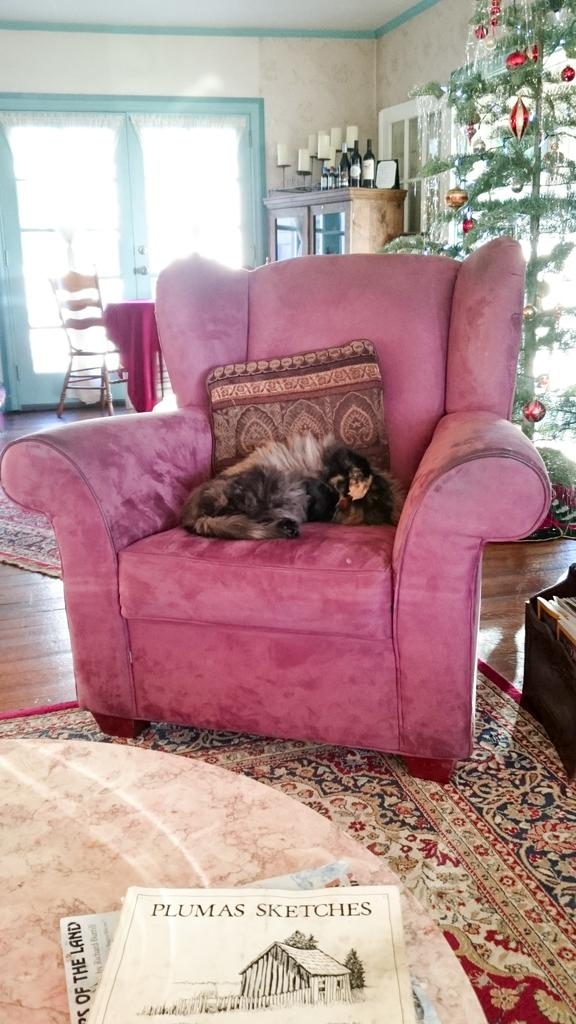What is the animal doing in the couch? The animal is sleeping in the couch. What is the animal using for support while sleeping? The animal has a pillow. What type of flooring is visible in the image? There is a carpet on the floor. What can be seen in the background of the image? There is a Christmas tree and a window in the background. What grade did the animal receive on its last report card? The image does not provide any information about the animal's academic performance or the existence of a report card. --- 